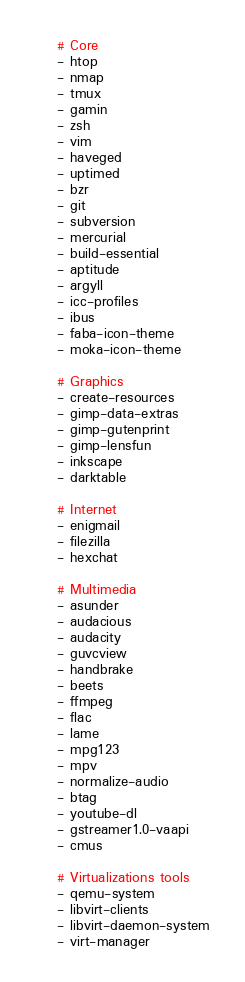<code> <loc_0><loc_0><loc_500><loc_500><_YAML_>    # Core
    - htop
    - nmap
    - tmux
    - gamin
    - zsh
    - vim
    - haveged
    - uptimed
    - bzr
    - git
    - subversion
    - mercurial
    - build-essential
    - aptitude
    - argyll
    - icc-profiles
    - ibus
    - faba-icon-theme
    - moka-icon-theme

    # Graphics
    - create-resources
    - gimp-data-extras
    - gimp-gutenprint
    - gimp-lensfun
    - inkscape
    - darktable

    # Internet
    - enigmail
    - filezilla
    - hexchat

    # Multimedia
    - asunder
    - audacious
    - audacity
    - guvcview
    - handbrake
    - beets
    - ffmpeg
    - flac
    - lame
    - mpg123
    - mpv
    - normalize-audio
    - btag
    - youtube-dl
    - gstreamer1.0-vaapi
    - cmus

    # Virtualizations tools
    - qemu-system
    - libvirt-clients
    - libvirt-daemon-system
    - virt-manager
</code> 